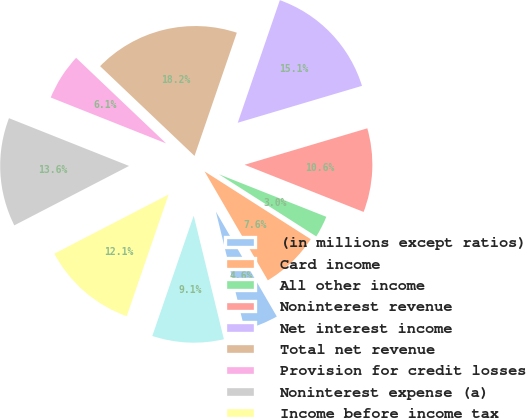Convert chart to OTSL. <chart><loc_0><loc_0><loc_500><loc_500><pie_chart><fcel>(in millions except ratios)<fcel>Card income<fcel>All other income<fcel>Noninterest revenue<fcel>Net interest income<fcel>Total net revenue<fcel>Provision for credit losses<fcel>Noninterest expense (a)<fcel>Income before income tax<fcel>Net income<nl><fcel>4.56%<fcel>7.58%<fcel>3.04%<fcel>10.6%<fcel>15.14%<fcel>18.17%<fcel>6.07%<fcel>13.63%<fcel>12.12%<fcel>9.09%<nl></chart> 